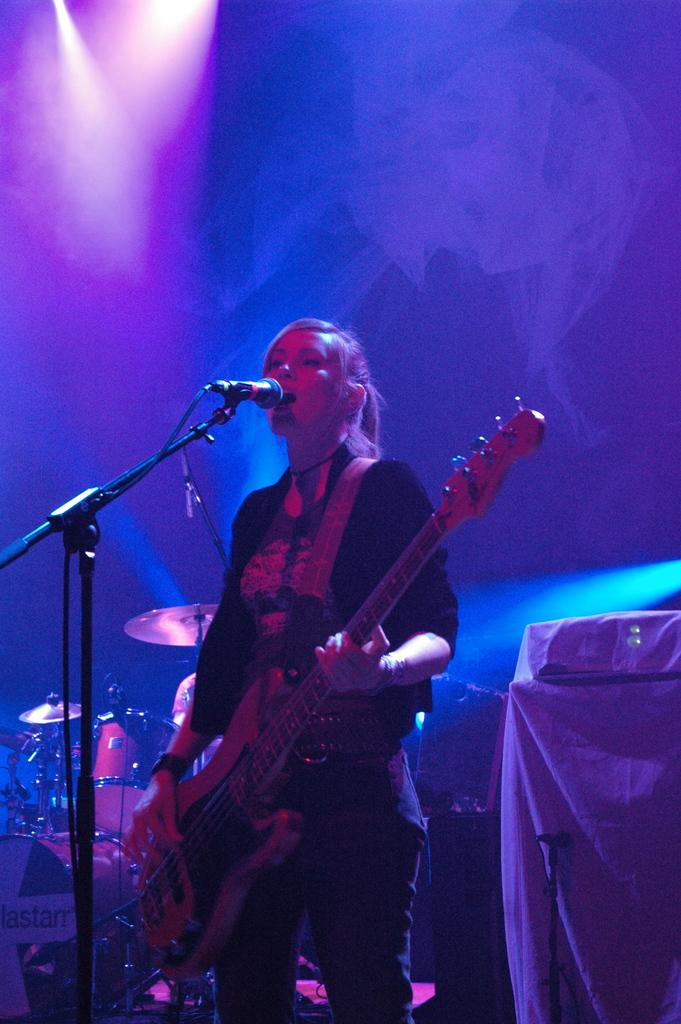Who is the main subject in the image? There is a woman in the image. What is the woman doing in the image? The woman is playing a guitar and singing into a microphone. What other musical instrument can be seen in the image? There are drums visible in the image. What type of lighting is present in the image? There are lights on the ceiling in the image. What thrill does the woman experience while playing the guitar in the image? There is no information about the woman's emotions or experiences while playing the guitar in the image. What observation can be made about the existence of a piano in the image? There is no piano present in the image. 